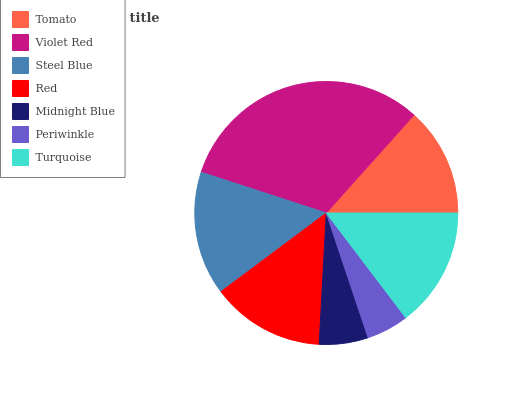Is Periwinkle the minimum?
Answer yes or no. Yes. Is Violet Red the maximum?
Answer yes or no. Yes. Is Steel Blue the minimum?
Answer yes or no. No. Is Steel Blue the maximum?
Answer yes or no. No. Is Violet Red greater than Steel Blue?
Answer yes or no. Yes. Is Steel Blue less than Violet Red?
Answer yes or no. Yes. Is Steel Blue greater than Violet Red?
Answer yes or no. No. Is Violet Red less than Steel Blue?
Answer yes or no. No. Is Red the high median?
Answer yes or no. Yes. Is Red the low median?
Answer yes or no. Yes. Is Periwinkle the high median?
Answer yes or no. No. Is Turquoise the low median?
Answer yes or no. No. 